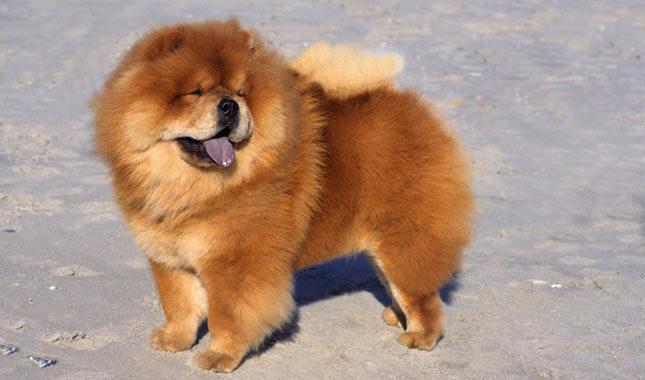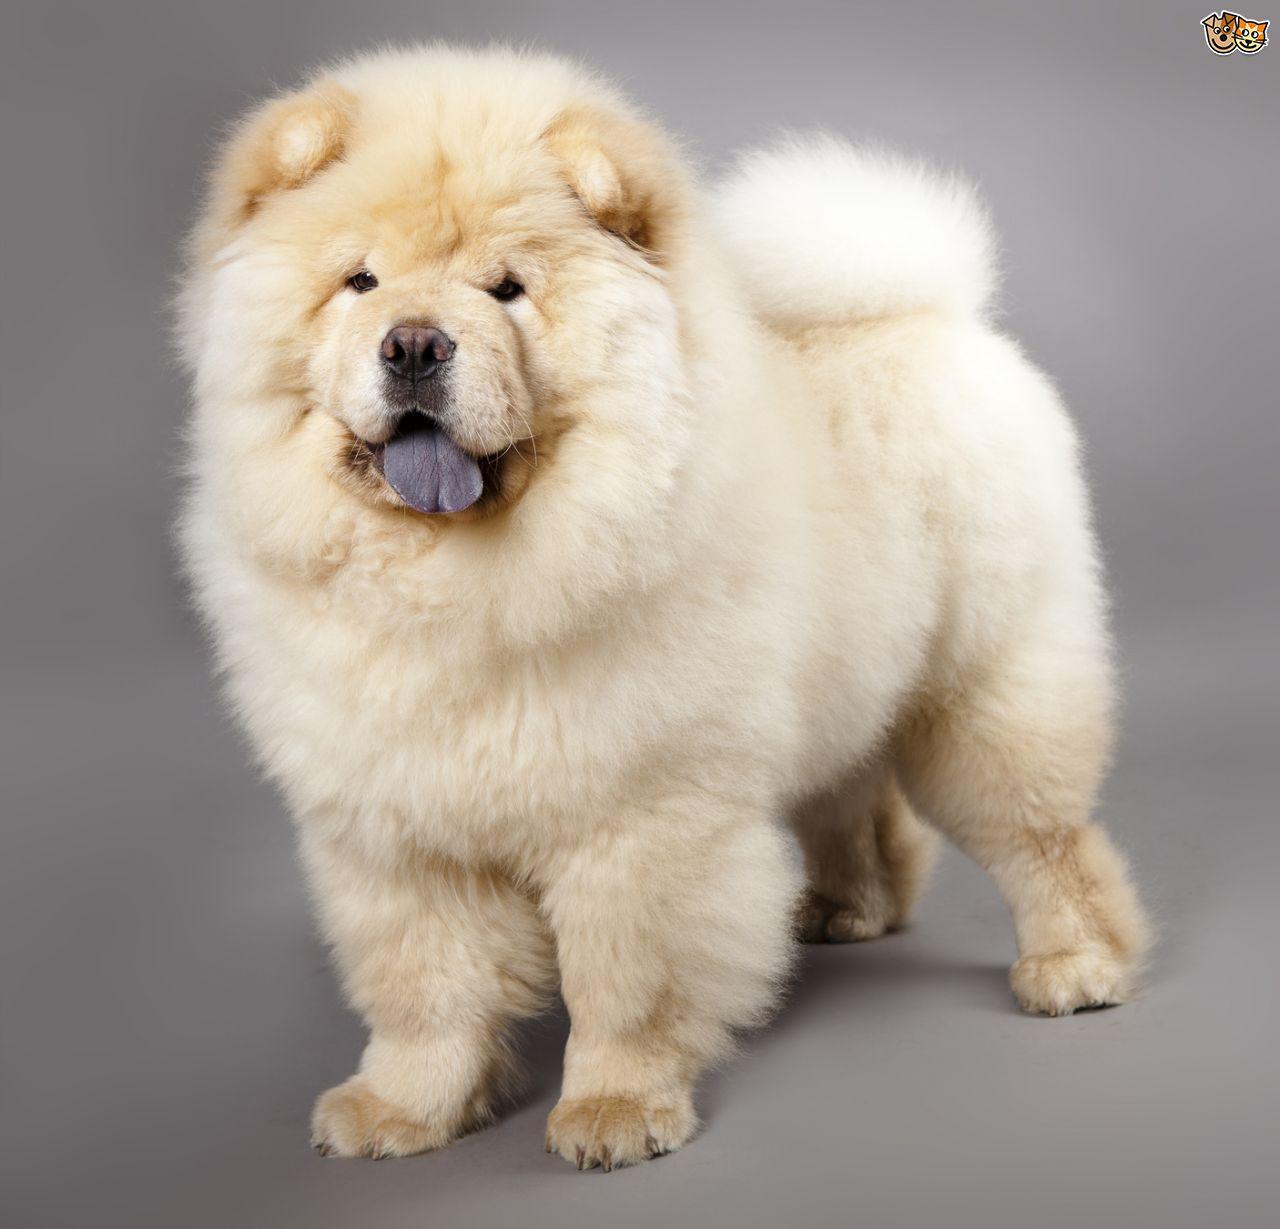The first image is the image on the left, the second image is the image on the right. Analyze the images presented: Is the assertion "An image shows a chow standing on a brick-type surface." valid? Answer yes or no. No. The first image is the image on the left, the second image is the image on the right. Examine the images to the left and right. Is the description "One of the images only shows the head of a dog." accurate? Answer yes or no. No. 